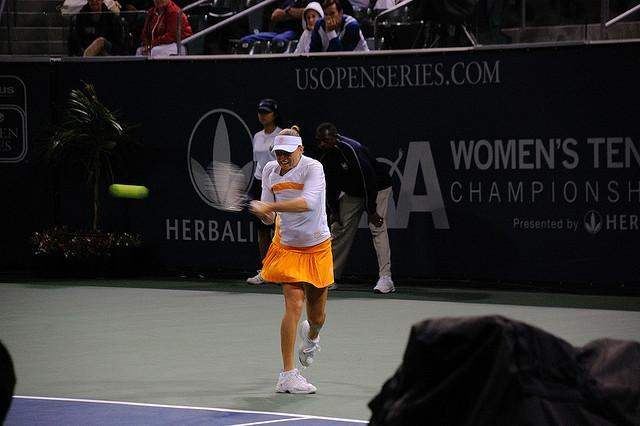Where is this tournament based?

Choices:
A) london
B) flushing meadows
C) poughkeepsie
D) little rock flushing meadows 